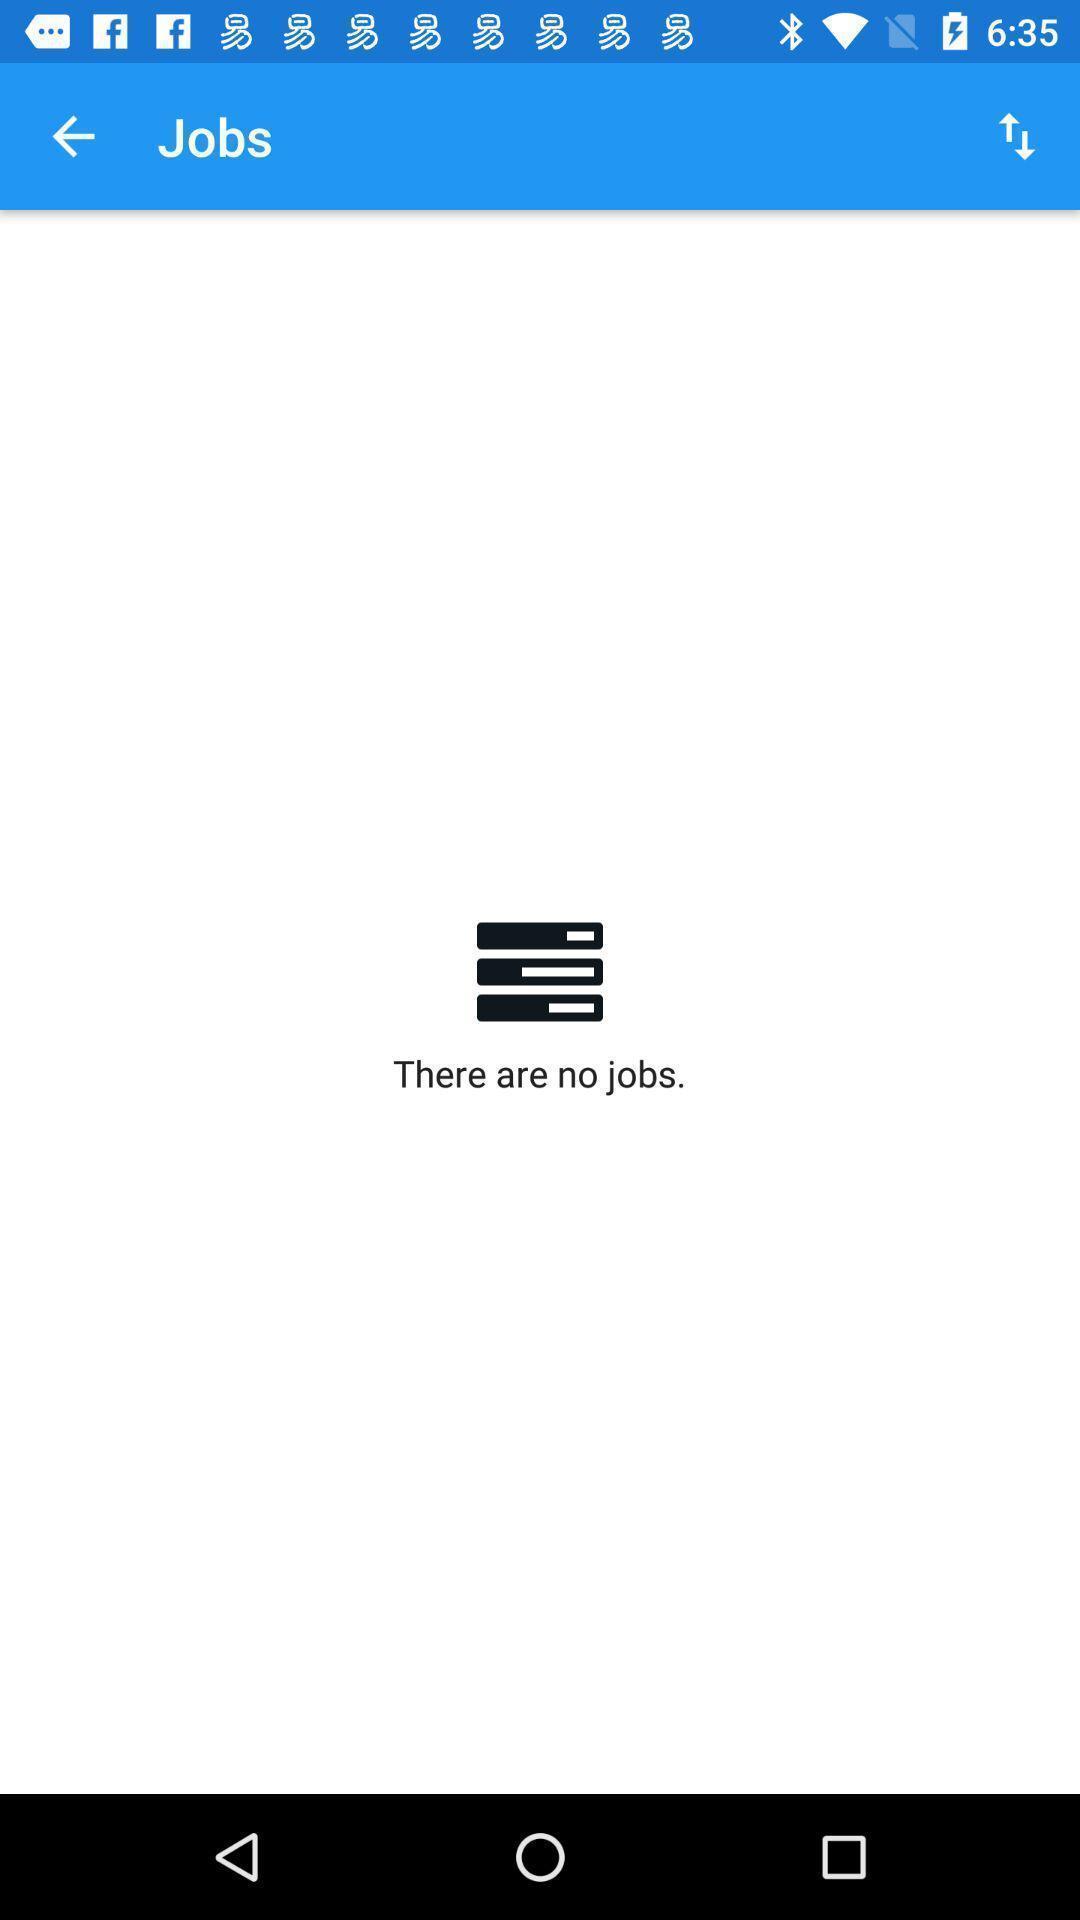Provide a textual representation of this image. Screen displays an empty page of no jobs. 